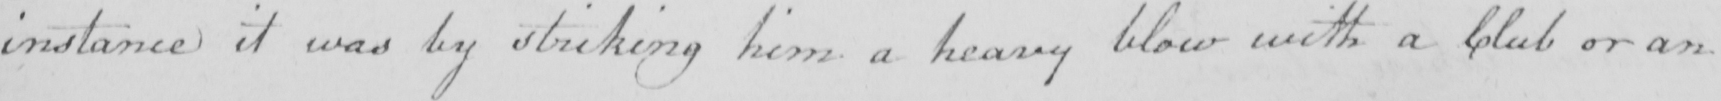What text is written in this handwritten line? instance it was by striking him a heavy blow with a Club or an 